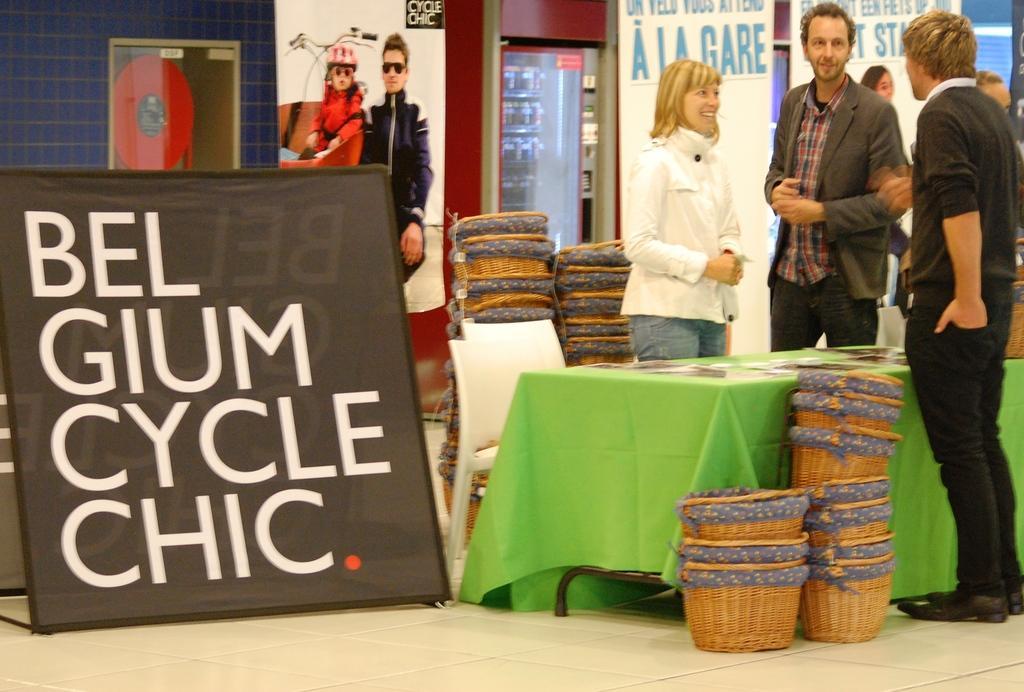Describe this image in one or two sentences. In this image on the right side there are some people who are standing, and they are talking with each other and there is a table. On the table there are some cards, and also we could see some baskets, chair, glass windows, wall and some objects. At the bottom there is floor. 